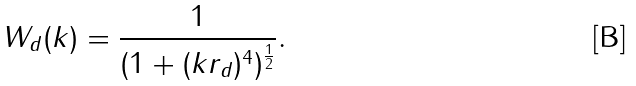<formula> <loc_0><loc_0><loc_500><loc_500>W _ { d } ( k ) = \frac { 1 } { ( 1 + ( k r _ { d } ) ^ { 4 } ) ^ { \frac { 1 } { 2 } } } .</formula> 